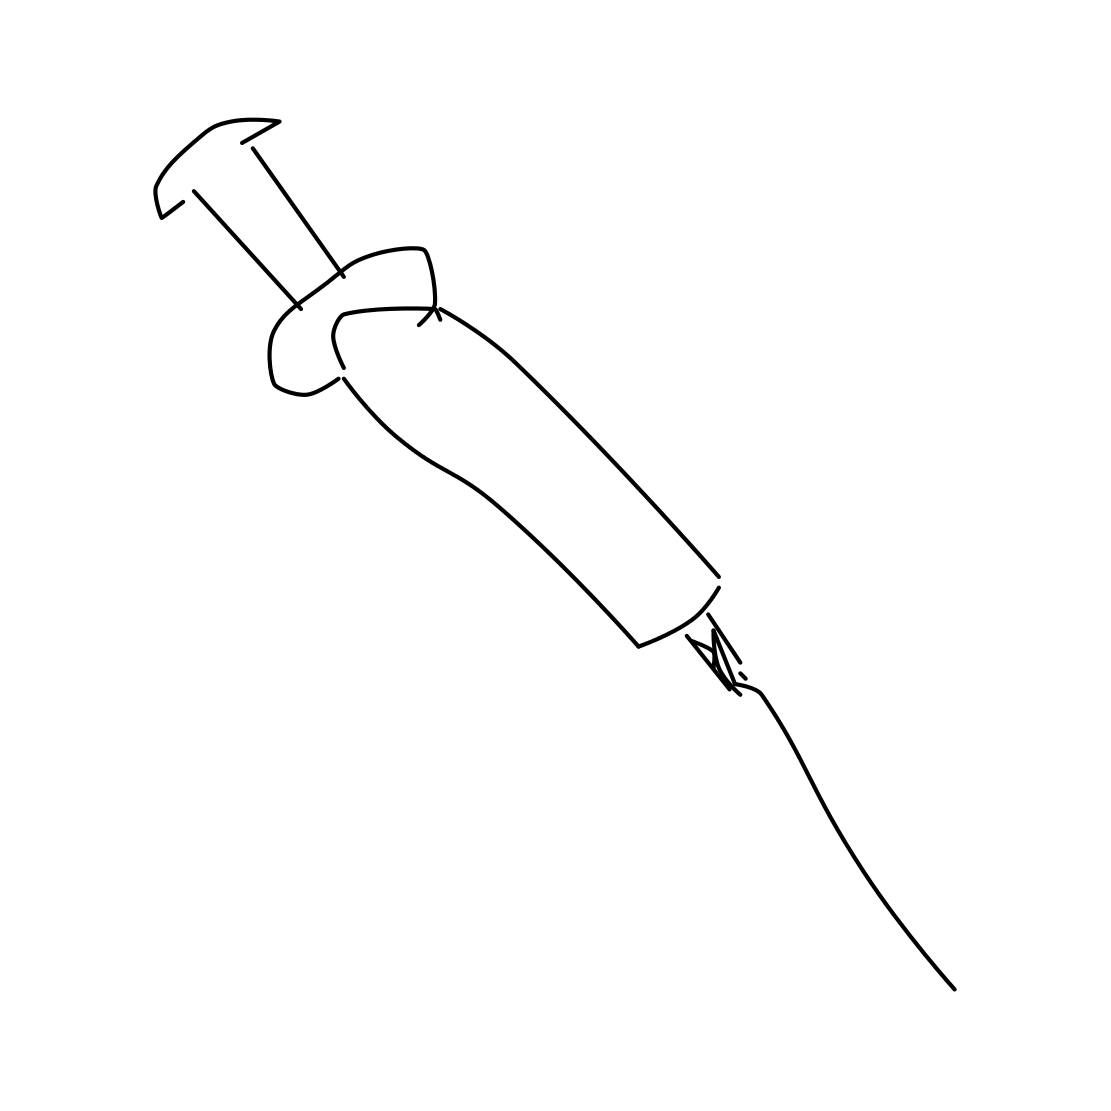Is there a sketchy syringe in the picture? Yes 